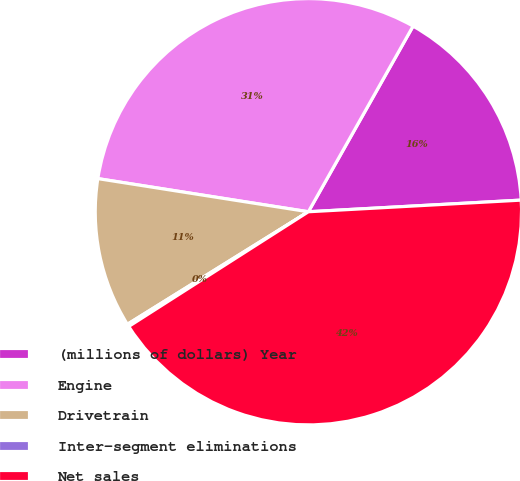Convert chart to OTSL. <chart><loc_0><loc_0><loc_500><loc_500><pie_chart><fcel>(millions of dollars) Year<fcel>Engine<fcel>Drivetrain<fcel>Inter-segment eliminations<fcel>Net sales<nl><fcel>15.96%<fcel>30.69%<fcel>11.34%<fcel>0.19%<fcel>41.83%<nl></chart> 